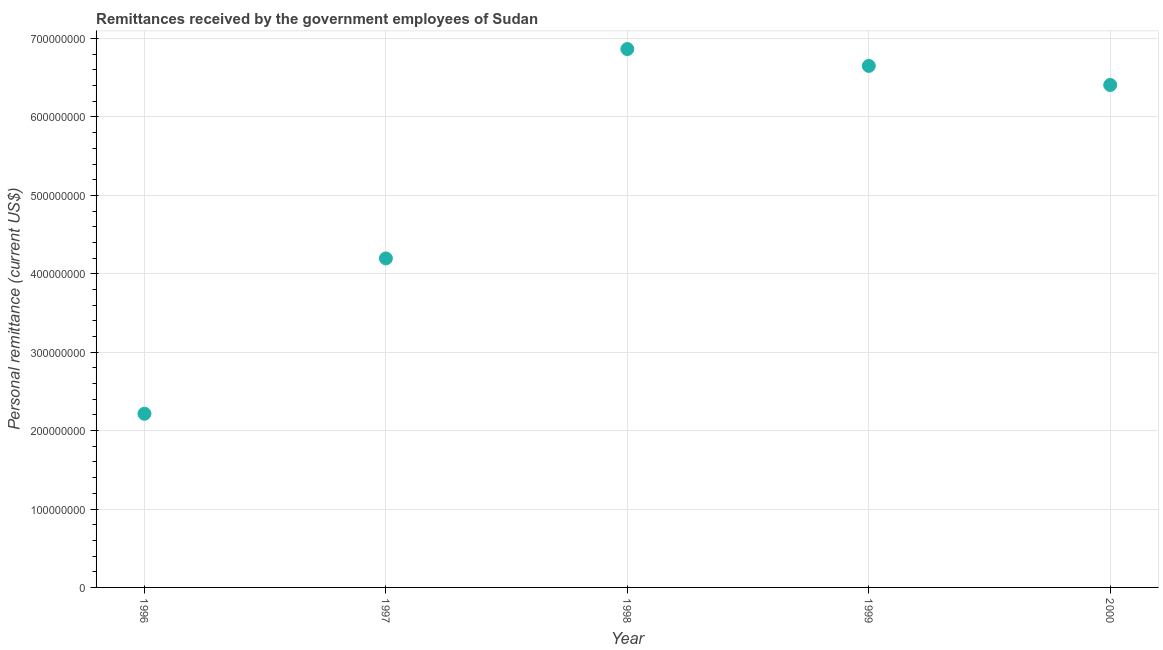What is the personal remittances in 1998?
Your response must be concise. 6.87e+08. Across all years, what is the maximum personal remittances?
Offer a terse response. 6.87e+08. Across all years, what is the minimum personal remittances?
Offer a very short reply. 2.22e+08. In which year was the personal remittances maximum?
Offer a terse response. 1998. What is the sum of the personal remittances?
Your answer should be compact. 2.63e+09. What is the difference between the personal remittances in 1996 and 1999?
Your answer should be compact. -4.44e+08. What is the average personal remittances per year?
Your response must be concise. 5.27e+08. What is the median personal remittances?
Ensure brevity in your answer.  6.41e+08. In how many years, is the personal remittances greater than 360000000 US$?
Your answer should be compact. 4. Do a majority of the years between 1997 and 1996 (inclusive) have personal remittances greater than 320000000 US$?
Offer a very short reply. No. What is the ratio of the personal remittances in 1996 to that in 2000?
Offer a terse response. 0.35. Is the personal remittances in 1996 less than that in 1998?
Ensure brevity in your answer.  Yes. Is the difference between the personal remittances in 1996 and 1998 greater than the difference between any two years?
Your response must be concise. Yes. What is the difference between the highest and the second highest personal remittances?
Offer a very short reply. 2.15e+07. What is the difference between the highest and the lowest personal remittances?
Offer a very short reply. 4.65e+08. Does the personal remittances monotonically increase over the years?
Provide a short and direct response. No. What is the difference between two consecutive major ticks on the Y-axis?
Your response must be concise. 1.00e+08. Does the graph contain any zero values?
Provide a succinct answer. No. Does the graph contain grids?
Ensure brevity in your answer.  Yes. What is the title of the graph?
Offer a very short reply. Remittances received by the government employees of Sudan. What is the label or title of the Y-axis?
Give a very brief answer. Personal remittance (current US$). What is the Personal remittance (current US$) in 1996?
Keep it short and to the point. 2.22e+08. What is the Personal remittance (current US$) in 1997?
Give a very brief answer. 4.20e+08. What is the Personal remittance (current US$) in 1998?
Provide a short and direct response. 6.87e+08. What is the Personal remittance (current US$) in 1999?
Provide a short and direct response. 6.65e+08. What is the Personal remittance (current US$) in 2000?
Ensure brevity in your answer.  6.41e+08. What is the difference between the Personal remittance (current US$) in 1996 and 1997?
Ensure brevity in your answer.  -1.98e+08. What is the difference between the Personal remittance (current US$) in 1996 and 1998?
Keep it short and to the point. -4.65e+08. What is the difference between the Personal remittance (current US$) in 1996 and 1999?
Give a very brief answer. -4.44e+08. What is the difference between the Personal remittance (current US$) in 1996 and 2000?
Make the answer very short. -4.19e+08. What is the difference between the Personal remittance (current US$) in 1997 and 1998?
Provide a short and direct response. -2.67e+08. What is the difference between the Personal remittance (current US$) in 1997 and 1999?
Your response must be concise. -2.45e+08. What is the difference between the Personal remittance (current US$) in 1997 and 2000?
Provide a succinct answer. -2.21e+08. What is the difference between the Personal remittance (current US$) in 1998 and 1999?
Provide a succinct answer. 2.15e+07. What is the difference between the Personal remittance (current US$) in 1998 and 2000?
Provide a succinct answer. 4.58e+07. What is the difference between the Personal remittance (current US$) in 1999 and 2000?
Keep it short and to the point. 2.43e+07. What is the ratio of the Personal remittance (current US$) in 1996 to that in 1997?
Provide a succinct answer. 0.53. What is the ratio of the Personal remittance (current US$) in 1996 to that in 1998?
Your response must be concise. 0.32. What is the ratio of the Personal remittance (current US$) in 1996 to that in 1999?
Give a very brief answer. 0.33. What is the ratio of the Personal remittance (current US$) in 1996 to that in 2000?
Your response must be concise. 0.35. What is the ratio of the Personal remittance (current US$) in 1997 to that in 1998?
Your answer should be compact. 0.61. What is the ratio of the Personal remittance (current US$) in 1997 to that in 1999?
Provide a succinct answer. 0.63. What is the ratio of the Personal remittance (current US$) in 1997 to that in 2000?
Provide a short and direct response. 0.66. What is the ratio of the Personal remittance (current US$) in 1998 to that in 1999?
Your answer should be compact. 1.03. What is the ratio of the Personal remittance (current US$) in 1998 to that in 2000?
Provide a succinct answer. 1.07. What is the ratio of the Personal remittance (current US$) in 1999 to that in 2000?
Keep it short and to the point. 1.04. 